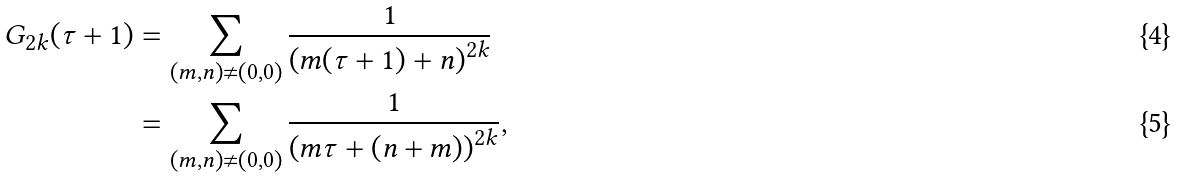<formula> <loc_0><loc_0><loc_500><loc_500>G _ { 2 k } ( \tau + 1 ) & = \sum _ { ( m , n ) \neq ( 0 , 0 ) } \frac { 1 } { \left ( m ( \tau + 1 ) + n \right ) ^ { 2 k } } \\ & = \sum _ { ( m , n ) \neq ( 0 , 0 ) } \frac { 1 } { \left ( m \tau + ( n + m ) \right ) ^ { 2 k } } ,</formula> 